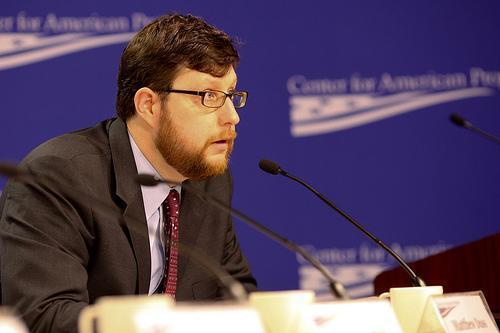How many people are in this picture?
Give a very brief answer. 1. How many microphones are in this picture?
Give a very brief answer. 4. How many mugs are in this picture?
Give a very brief answer. 3. 